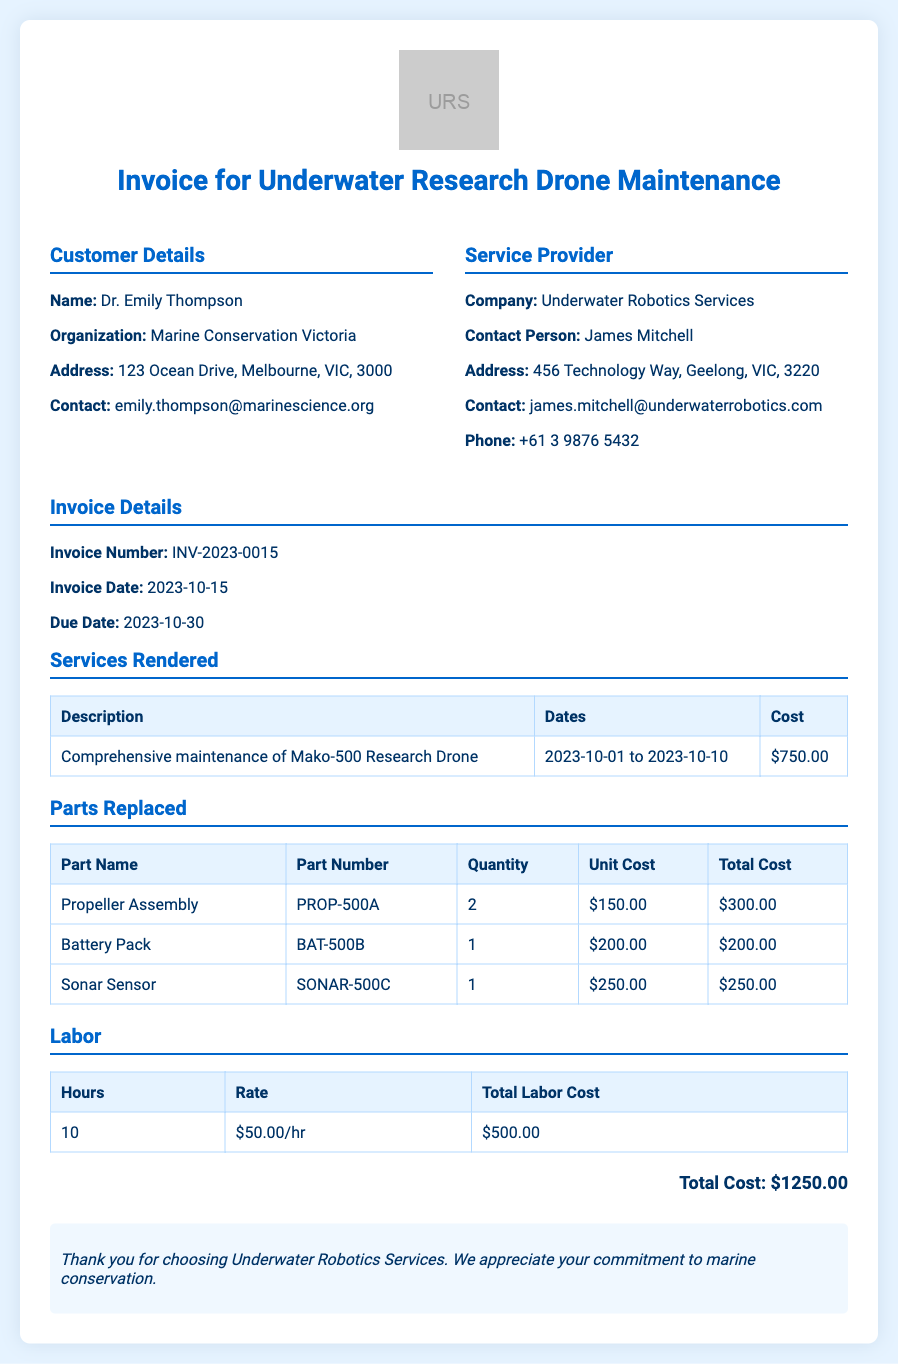what is the invoice number? The invoice number is specifically listed in the document to identify the transaction, which is INV-2023-0015.
Answer: INV-2023-0015 who is the contact person for the service provider? The contact person is an individual from the service provider's side, stated in the document as James Mitchell.
Answer: James Mitchell what is the total labor cost? The total labor cost is explicitly mentioned under the labor section, which shows a total of $500.00.
Answer: $500.00 how many hours of labor were performed? The document specifies the total hours worked in the labor section, which is 10 hours.
Answer: 10 what is the due date for the invoice? The due date is provided to indicate when payment must be made, which is 2023-10-30.
Answer: 2023-10-30 what is the cost of the Battery Pack part? The cost for the Battery Pack is mentioned in the table that lists parts replaced, which is $200.00.
Answer: $200.00 which part has the highest total cost? To determine the part with the highest cost, we compare totals in the parts table, which shows that the Propeller Assembly has the highest total cost of $300.00.
Answer: Propeller Assembly what dates does the service cover? The service dates are indicated in the services rendered section, covering from 2023-10-01 to 2023-10-10.
Answer: 2023-10-01 to 2023-10-10 